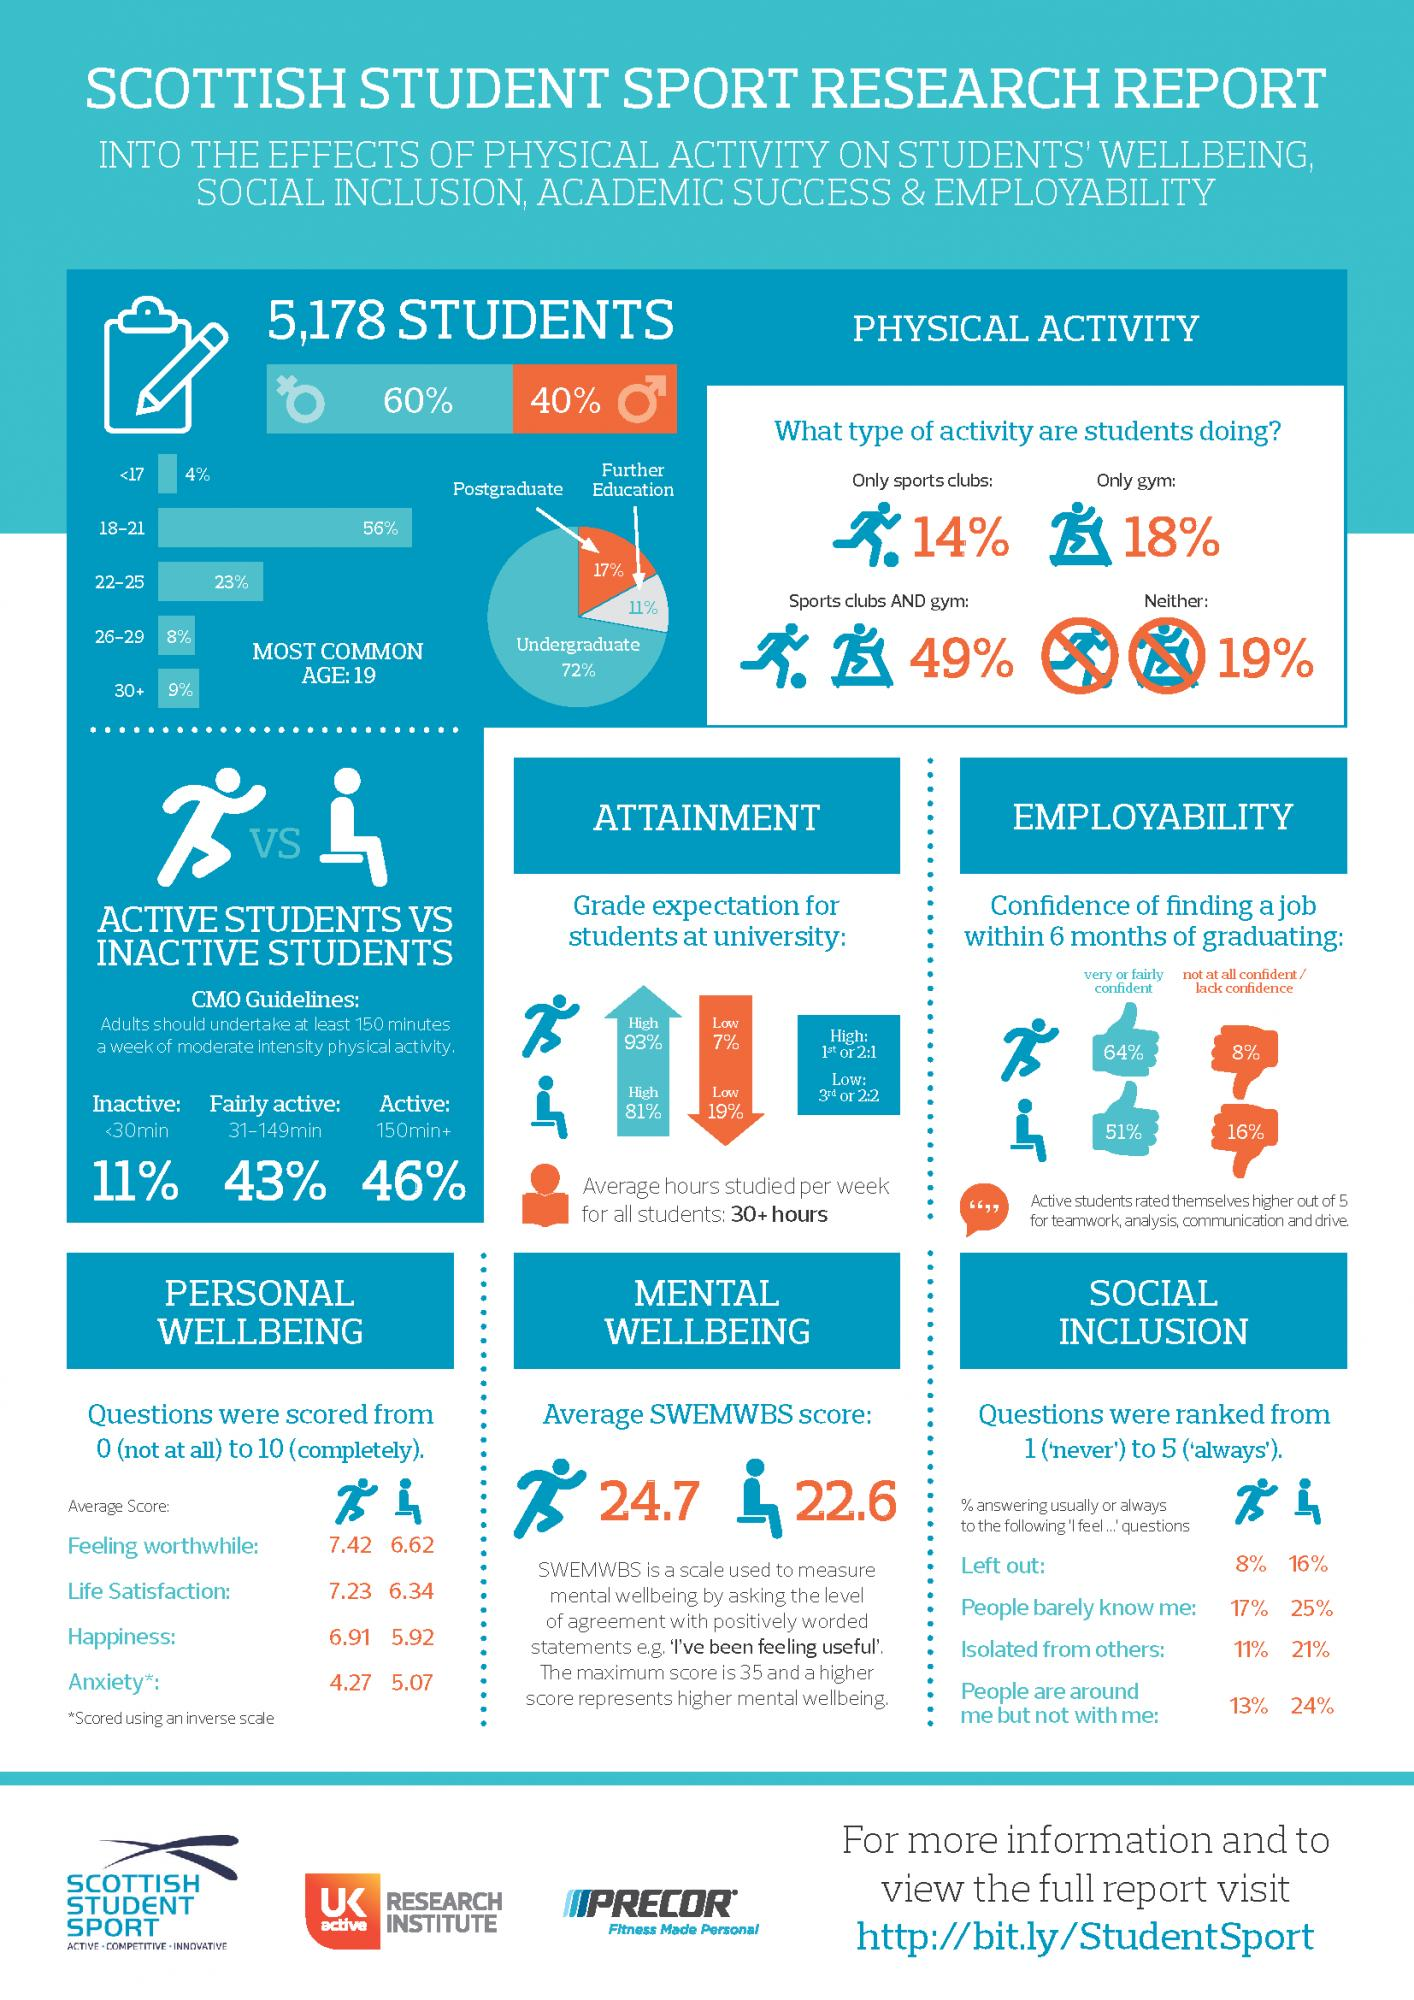Identify some key points in this picture. The SWEMWBS score for inactive students was 22.6. Out of the total number of 5178 students, 40% are male. The average score of active students for life satisfaction was 7.23. A majority of students are within the age group of 26 and above. Of the 5,178 students, 60% are female. 